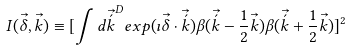Convert formula to latex. <formula><loc_0><loc_0><loc_500><loc_500>I { ( \vec { \delta } , \vec { k } ) } \equiv [ \int { { d \vec { \acute { k } } } ^ { D } { { e x p } { ( \imath \vec { \delta } \cdot \vec { \acute { k } } ) } } { \beta { ( \vec { \acute { k } } - { \frac { 1 } { 2 } \vec { k } } ) } } { \beta { ( \vec { \acute { k } } + { \frac { 1 } { 2 } \vec { k } } ) } } } ] ^ { 2 }</formula> 